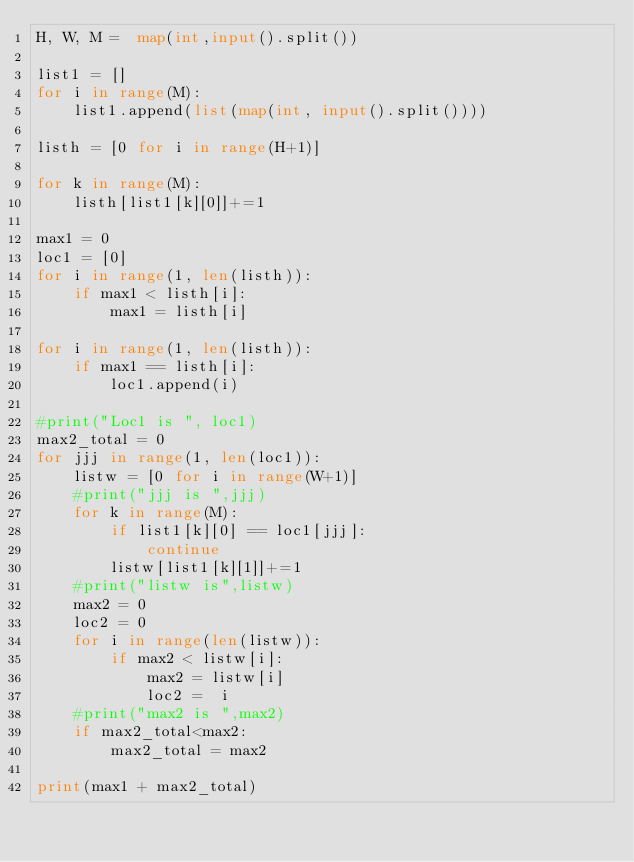<code> <loc_0><loc_0><loc_500><loc_500><_Python_>H, W, M =  map(int,input().split())

list1 = []
for i in range(M):
    list1.append(list(map(int, input().split())))

listh = [0 for i in range(H+1)]

for k in range(M):
    listh[list1[k][0]]+=1

max1 = 0
loc1 = [0]
for i in range(1, len(listh)):
    if max1 < listh[i]:
        max1 = listh[i]

for i in range(1, len(listh)):
    if max1 == listh[i]:
        loc1.append(i)

#print("Loc1 is ", loc1)
max2_total = 0
for jjj in range(1, len(loc1)):
    listw = [0 for i in range(W+1)]
    #print("jjj is ",jjj)
    for k in range(M):
        if list1[k][0] == loc1[jjj]:
            continue
        listw[list1[k][1]]+=1
    #print("listw is",listw)
    max2 = 0
    loc2 = 0
    for i in range(len(listw)):
        if max2 < listw[i]:
            max2 = listw[i]
            loc2 =  i
    #print("max2 is ",max2)
    if max2_total<max2:
        max2_total = max2

print(max1 + max2_total)
</code> 